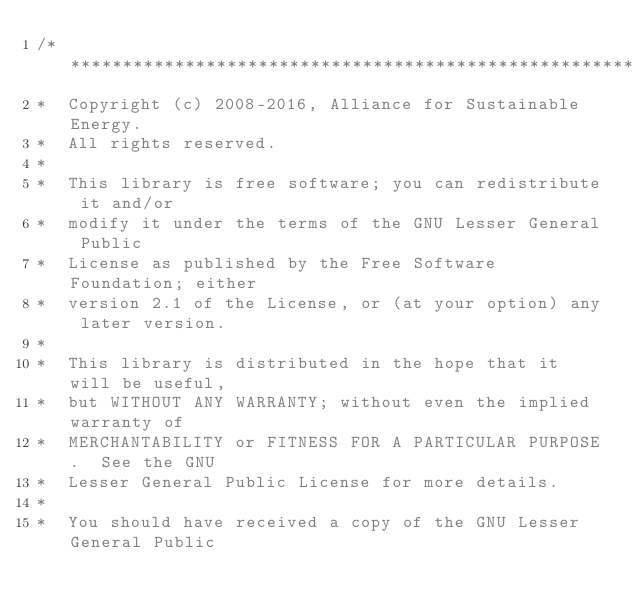<code> <loc_0><loc_0><loc_500><loc_500><_C++_>/**********************************************************************
*  Copyright (c) 2008-2016, Alliance for Sustainable Energy.  
*  All rights reserved.
*  
*  This library is free software; you can redistribute it and/or
*  modify it under the terms of the GNU Lesser General Public
*  License as published by the Free Software Foundation; either
*  version 2.1 of the License, or (at your option) any later version.
*  
*  This library is distributed in the hope that it will be useful,
*  but WITHOUT ANY WARRANTY; without even the implied warranty of
*  MERCHANTABILITY or FITNESS FOR A PARTICULAR PURPOSE.  See the GNU
*  Lesser General Public License for more details.
*  
*  You should have received a copy of the GNU Lesser General Public</code> 